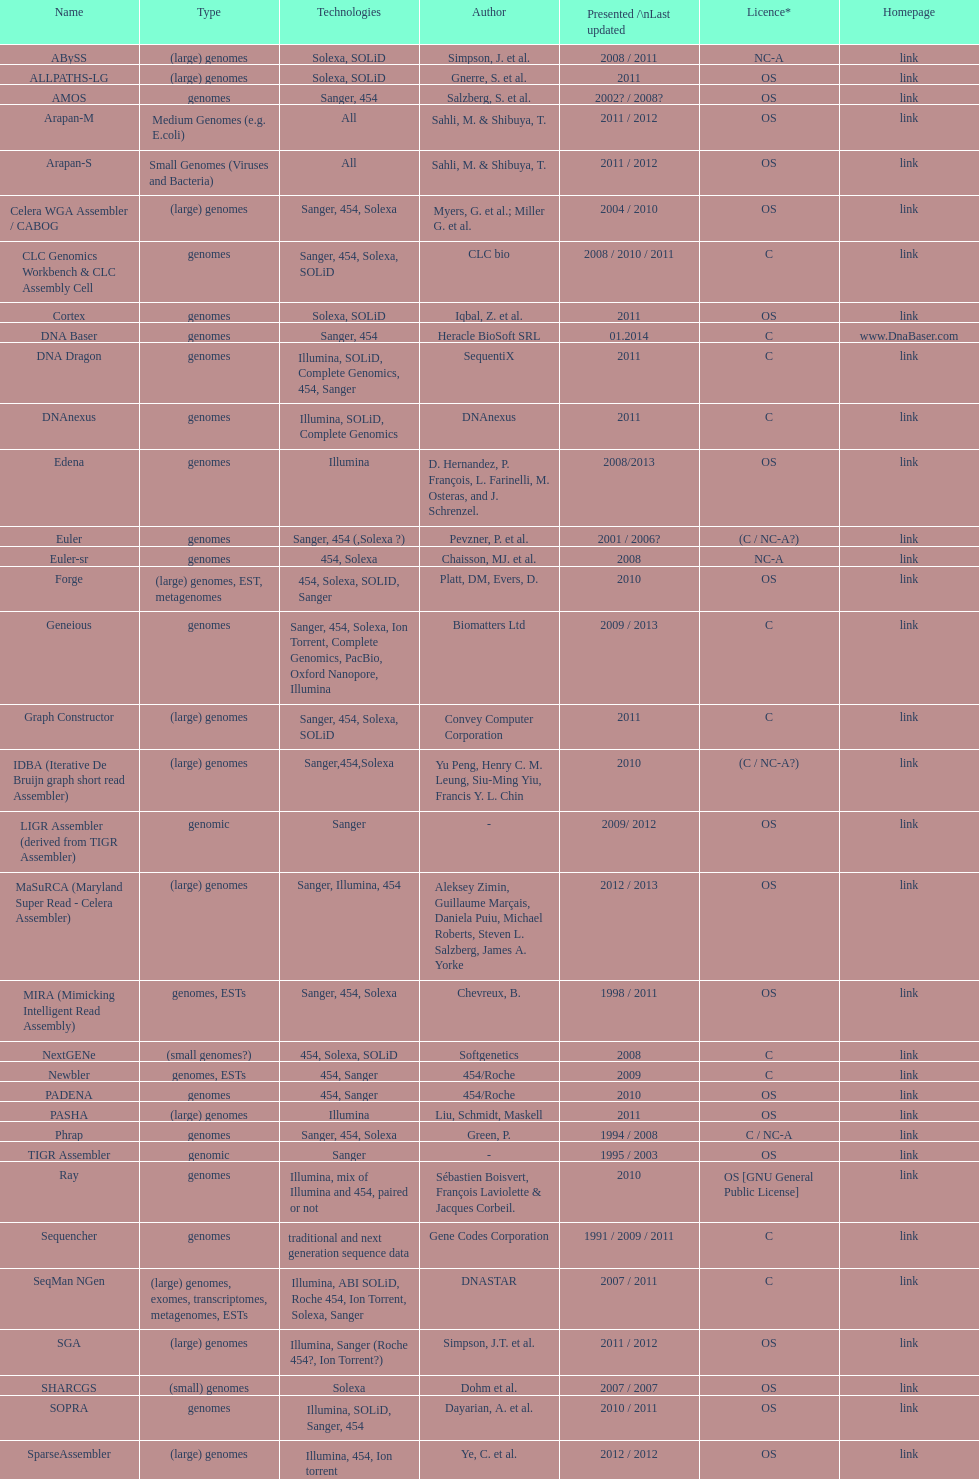Between os and c licenses, which one is mentioned more often? OS. 